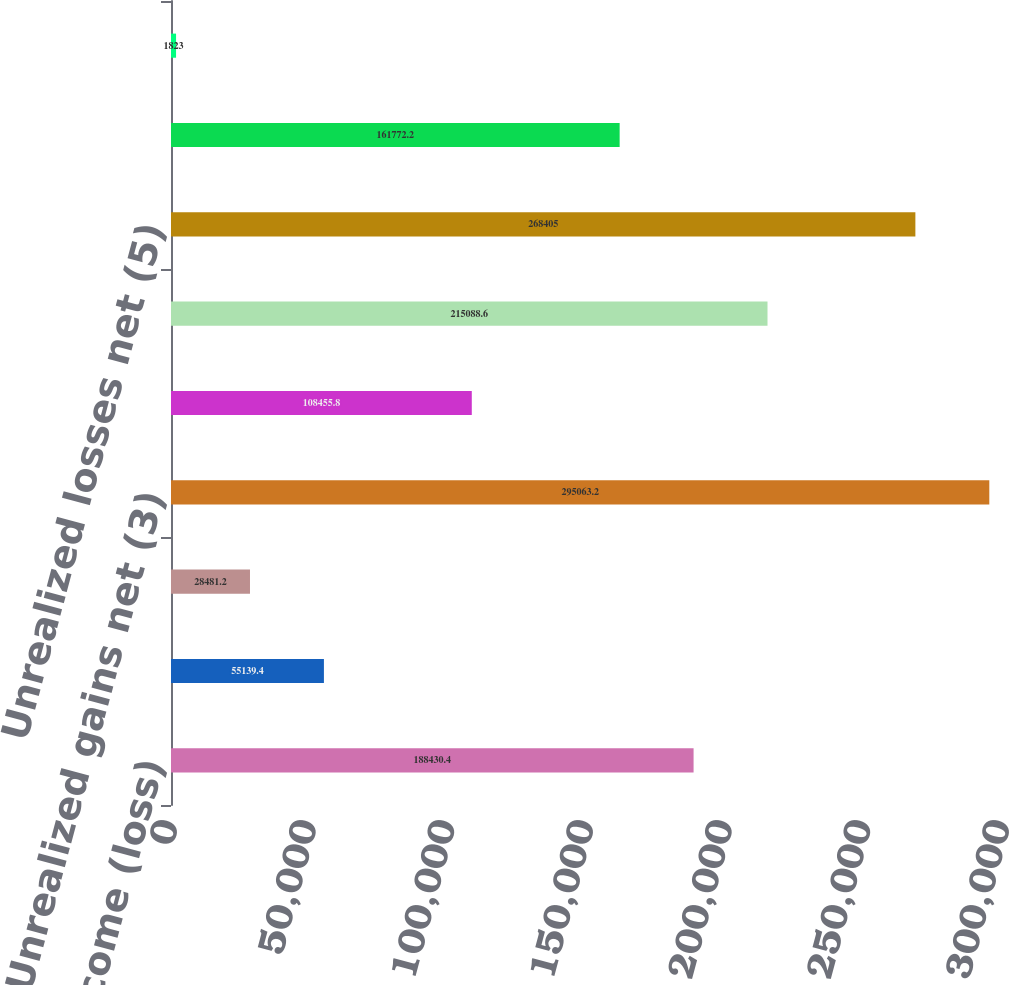<chart> <loc_0><loc_0><loc_500><loc_500><bar_chart><fcel>Net income (loss)<fcel>OTTI net (1)<fcel>Noncredit portion of OTTI<fcel>Unrealized gains net (3)<fcel>Reclassification into earnings<fcel>Net change from<fcel>Unrealized losses net (5)<fcel>Net change from cash flow<fcel>Foreign currency translation<nl><fcel>188430<fcel>55139.4<fcel>28481.2<fcel>295063<fcel>108456<fcel>215089<fcel>268405<fcel>161772<fcel>1823<nl></chart> 